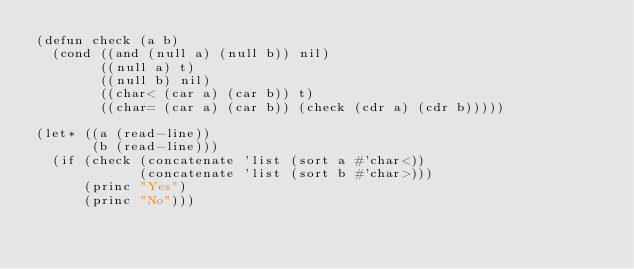<code> <loc_0><loc_0><loc_500><loc_500><_Lisp_>(defun check (a b)
  (cond ((and (null a) (null b)) nil)
        ((null a) t)
        ((null b) nil)
        ((char< (car a) (car b)) t)
        ((char= (car a) (car b)) (check (cdr a) (cdr b)))))

(let* ((a (read-line))
       (b (read-line)))
  (if (check (concatenate 'list (sort a #'char<))
             (concatenate 'list (sort b #'char>)))
      (princ "Yes")
      (princ "No")))
</code> 